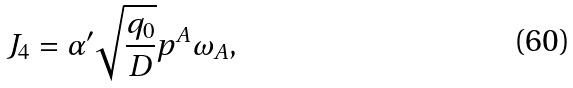Convert formula to latex. <formula><loc_0><loc_0><loc_500><loc_500>J _ { 4 } = \alpha ^ { \prime } \sqrt { \frac { q _ { 0 } } { D } } p ^ { A } \omega _ { A } ,</formula> 